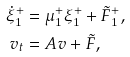Convert formula to latex. <formula><loc_0><loc_0><loc_500><loc_500>\dot { \xi } _ { 1 } ^ { + } & = \mu ^ { + } _ { 1 } \xi ^ { + } _ { 1 } + \tilde { F } ^ { + } _ { 1 } , \\ v _ { t } & = A v + \tilde { F } ,</formula> 